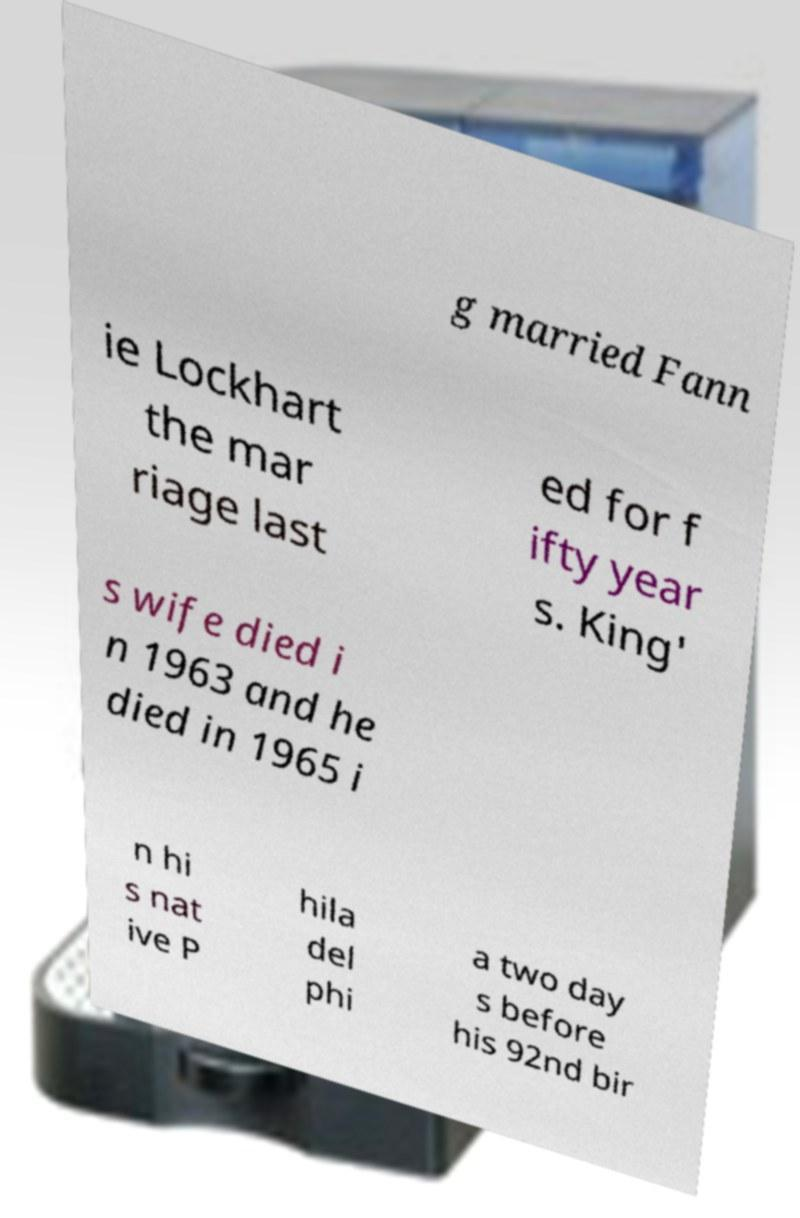I need the written content from this picture converted into text. Can you do that? g married Fann ie Lockhart the mar riage last ed for f ifty year s. King' s wife died i n 1963 and he died in 1965 i n hi s nat ive P hila del phi a two day s before his 92nd bir 